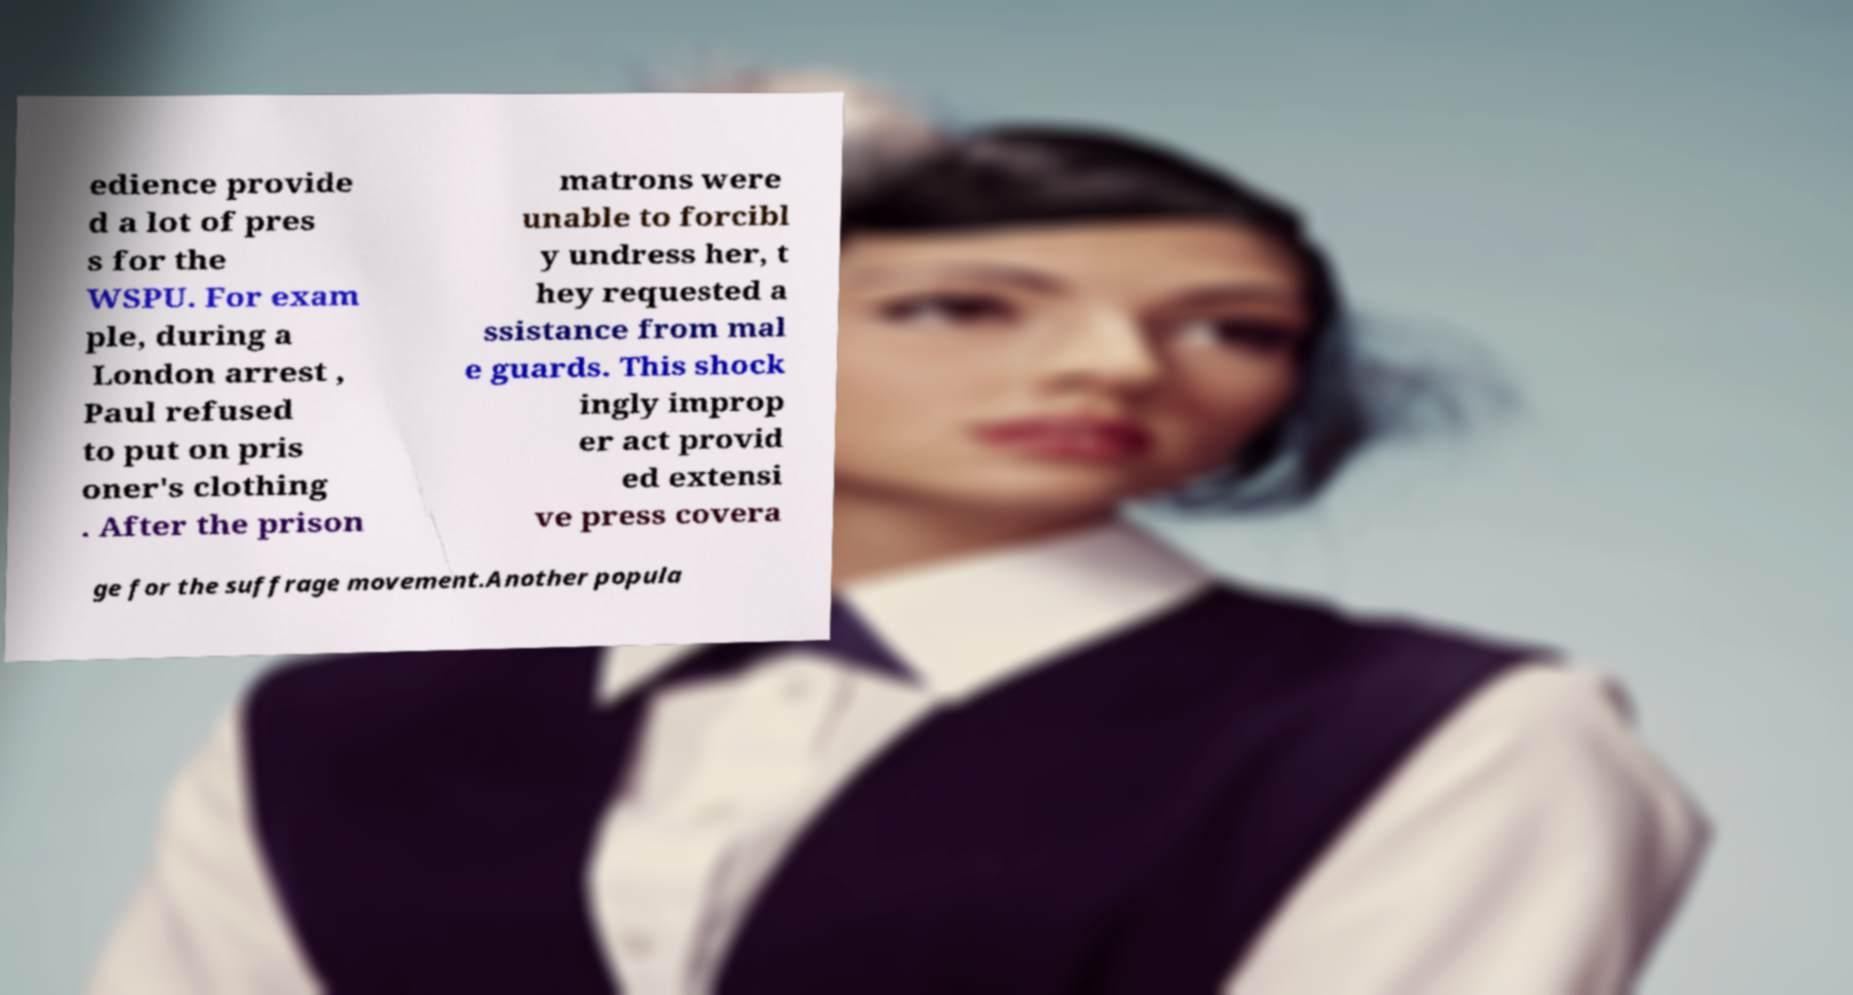Please identify and transcribe the text found in this image. edience provide d a lot of pres s for the WSPU. For exam ple, during a London arrest , Paul refused to put on pris oner's clothing . After the prison matrons were unable to forcibl y undress her, t hey requested a ssistance from mal e guards. This shock ingly improp er act provid ed extensi ve press covera ge for the suffrage movement.Another popula 